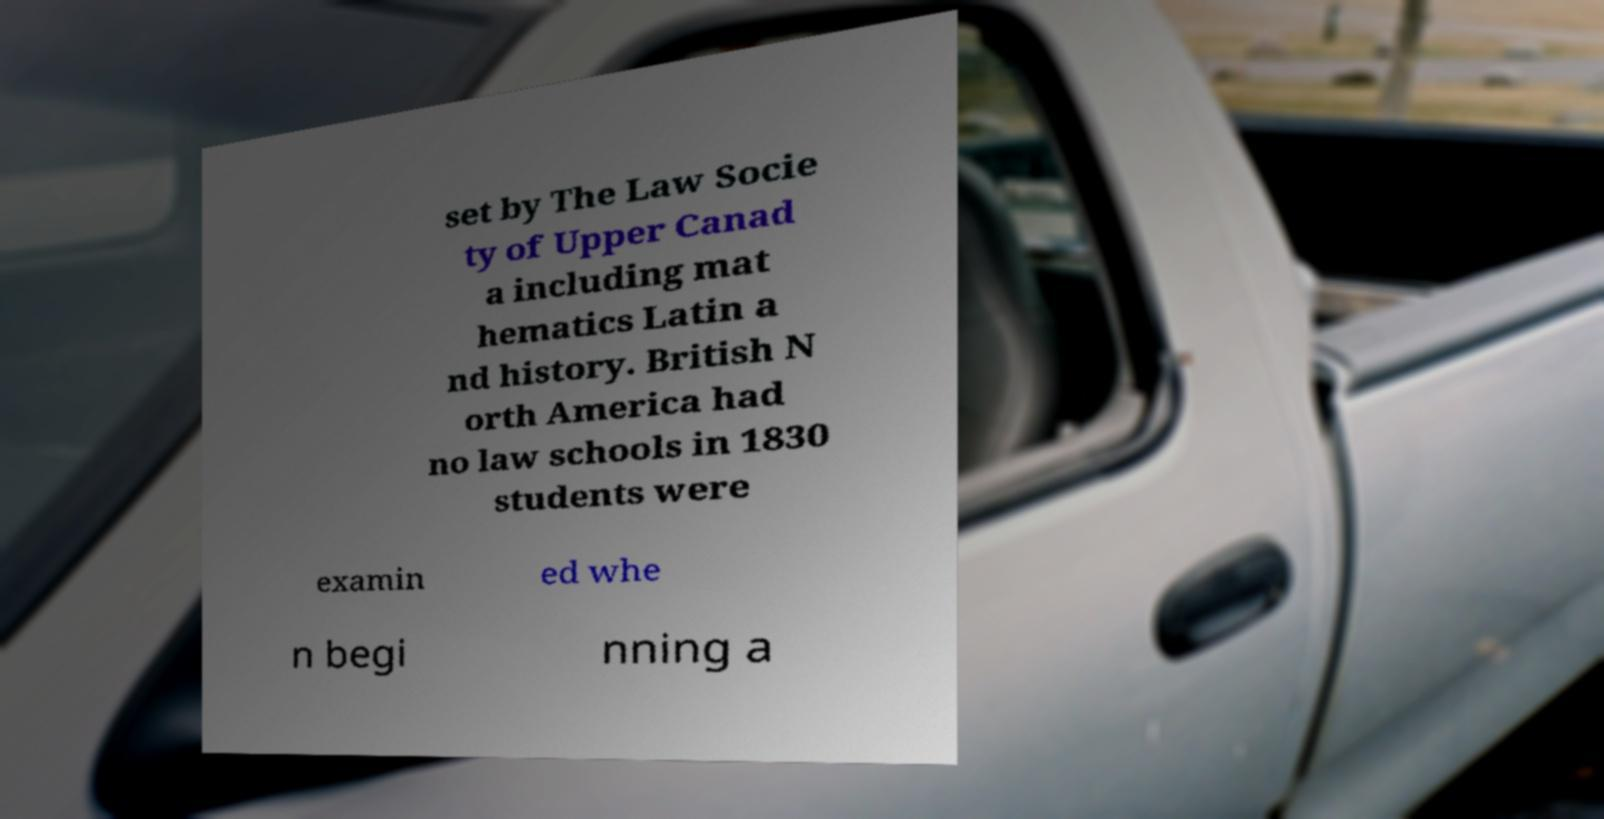There's text embedded in this image that I need extracted. Can you transcribe it verbatim? set by The Law Socie ty of Upper Canad a including mat hematics Latin a nd history. British N orth America had no law schools in 1830 students were examin ed whe n begi nning a 